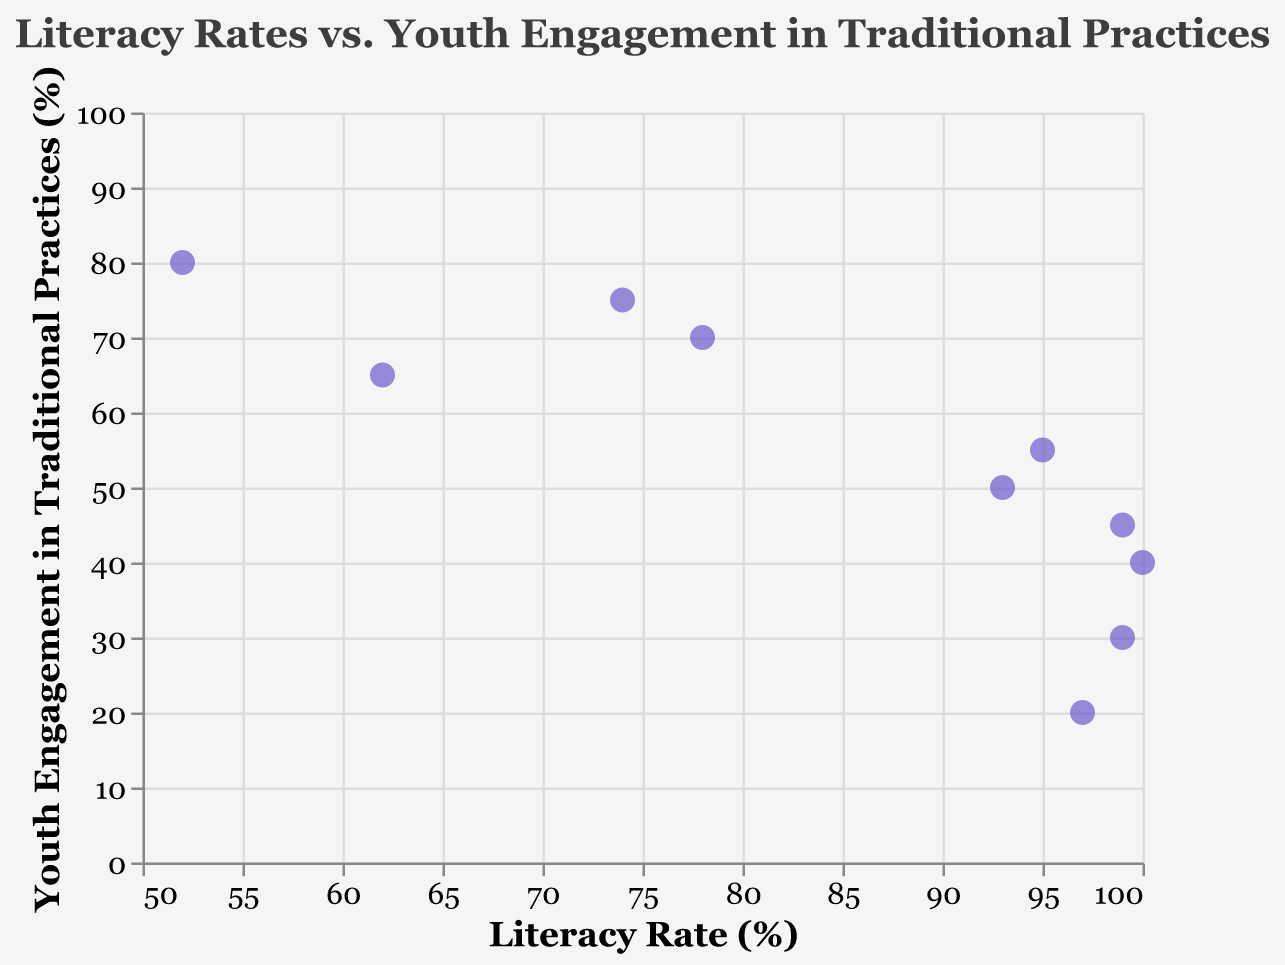What's the title of the figure? The title of the figure is usually placed on the top center of the chart. In this case, the title is shown in the code snippet as "Literacy Rates vs. Youth Engagement in Traditional Practices".
Answer: Literacy Rates vs. Youth Engagement in Traditional Practices What is the literacy rate of Japan? The data point for Japan can be identified on the scatter plot, and the literacy rate can be found by looking at the position on the x-axis. According to the data, Japan has a literacy rate of 99%.
Answer: 99% How many data points are shown in the scatter plot? Each country in the provided data represents one data point on the scatter plot. By counting the number of countries listed, we find there are 10 data points.
Answer: 10 Which country has the highest engagement in traditional practices? To find this, look at the y-axis, which represents the engagement in traditional practices. The data point with the highest y-axis value corresponds to Ethiopia with 80%.
Answer: Ethiopia Which country has the lowest literacy rate? To determine the lowest literacy rate, check the x-axis values for each data point. The country with the lowest x-axis value is Ethiopia with a literacy rate of 52%.
Answer: Ethiopia Which countries have both a literacy rate above 90% and youth engagement in traditional practices below 50%? To solve this, identify the countries with x-axis values above 90 and y-axis values below 50. The countries fitting these criteria are Japan (99, 45), United States (99, 30), Russia (100, 40), and China (97, 20).
Answer: Japan, United States, Russia, China What's the average youth engagement in traditional practices for countries with a literacy rate below 80%? First identify the relevant countries: India (75), Ethiopia (80), and Kenya (70). Calculate the average: (75 + 80 + 70) / 3 = 225 / 3 = 75.
Answer: 75 Compare the literacy rates of Brazil and Mexico. Which one is higher? Find the respective data points on the scatter plot: Brazil has a literacy rate of 93% and Mexico has a literacy rate of 95%.
Answer: Mexico Is there an observable trend between literacy rates and youth engagement in traditional practices? By visually inspecting the data points in the scatter plot, it seems there is no clear linear relationship or trend between the literacy rates and youth engagement in traditional practices; the points are scattered without a clear pattern.
Answer: No clear trend Which country has the closest literacy rate to 75% and what is its youth engagement in traditional practices? Look for the data point closest to 75% on the x-axis. India has a literacy rate of 74% and youth engagement in traditional practices of 75%.
Answer: India, 75% 